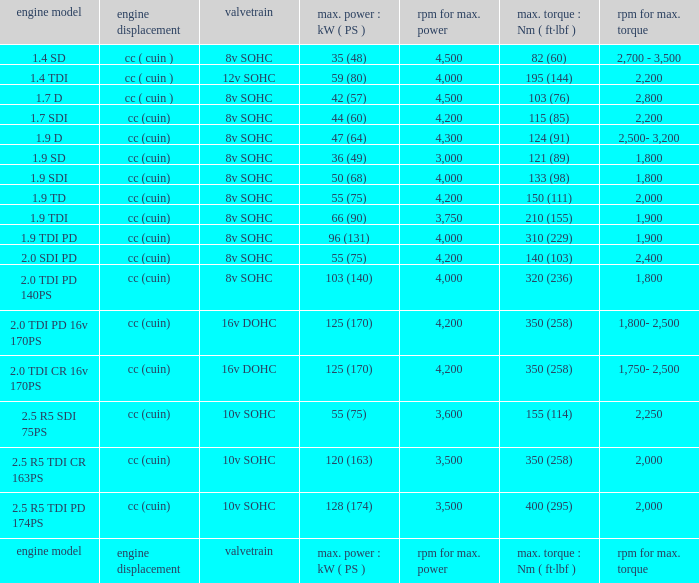What type of valvetrain does an engine model have when it is an engine model itself? Valvetrain. 